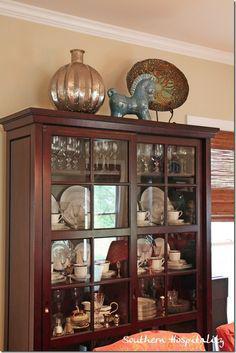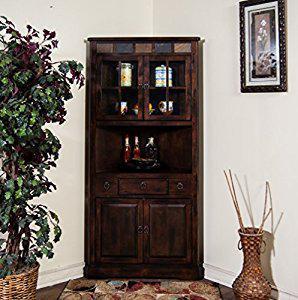The first image is the image on the left, the second image is the image on the right. Evaluate the accuracy of this statement regarding the images: "There is one picture frame in the image on the right.". Is it true? Answer yes or no. Yes. The first image is the image on the left, the second image is the image on the right. Evaluate the accuracy of this statement regarding the images: "One of the wooden cabinets is not flat across the top.". Is it true? Answer yes or no. No. 